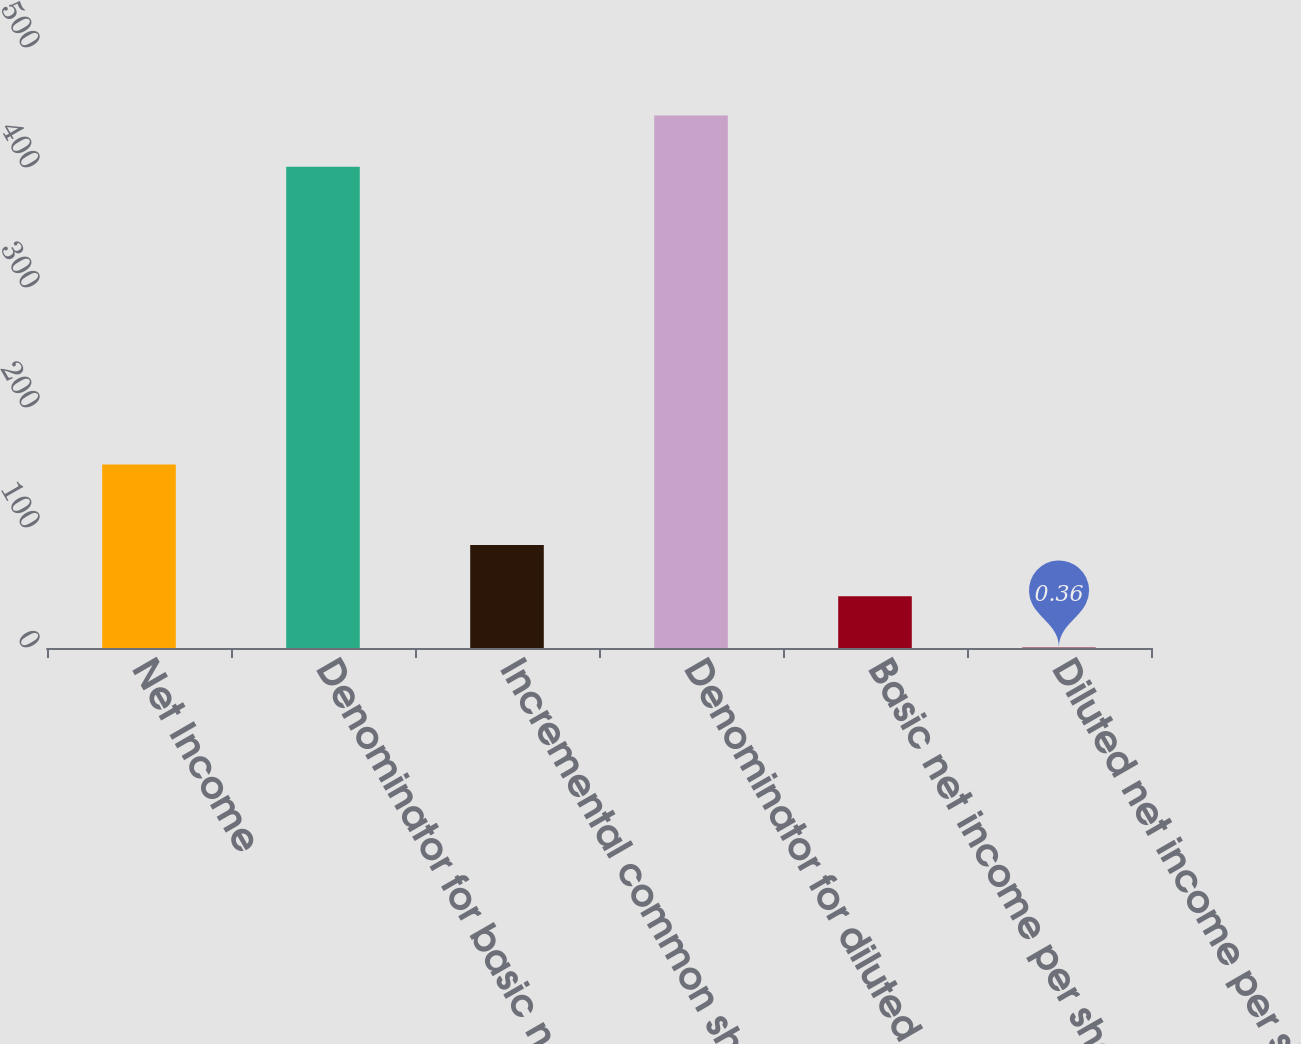Convert chart. <chart><loc_0><loc_0><loc_500><loc_500><bar_chart><fcel>Net Income<fcel>Denominator for basic net<fcel>Incremental common shares<fcel>Denominator for diluted net<fcel>Basic net income per share<fcel>Diluted net income per share<nl><fcel>153<fcel>401<fcel>85.88<fcel>443.76<fcel>43.12<fcel>0.36<nl></chart> 